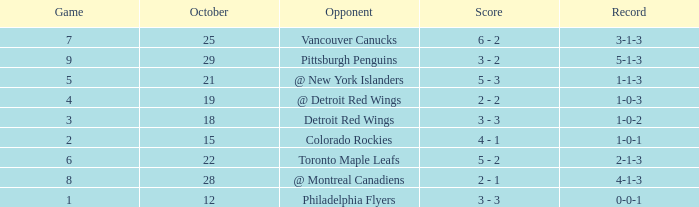Name the most october for game less than 1 None. 